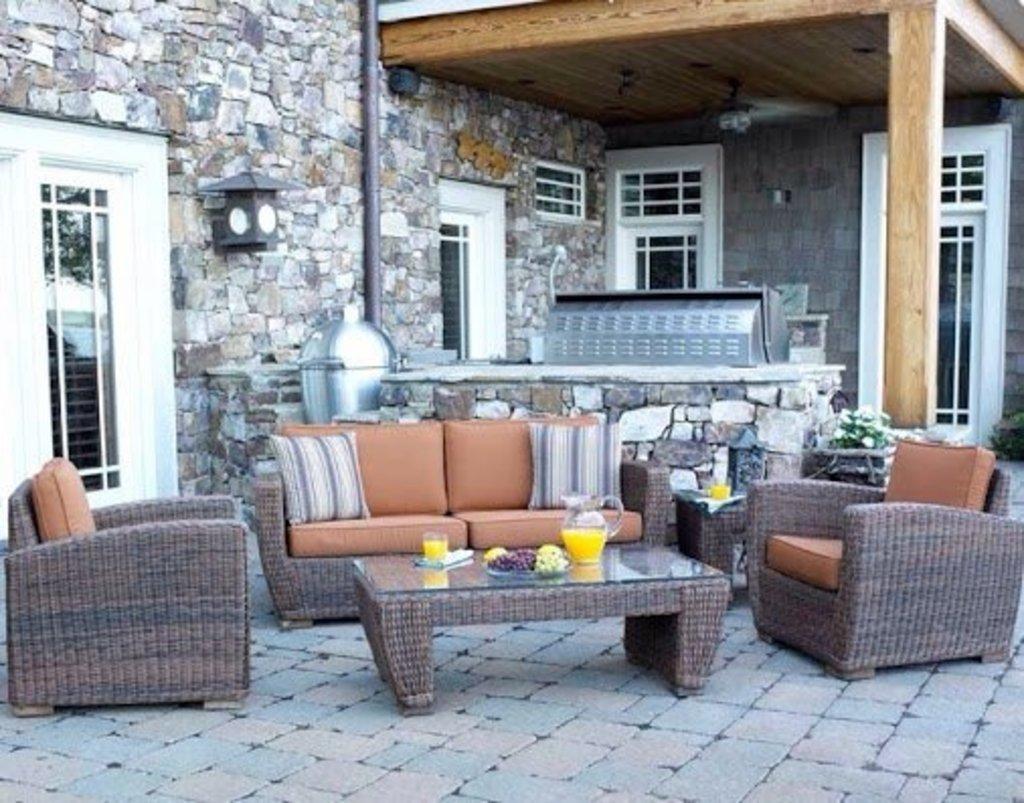Please provide a concise description of this image. There are sofa, pillow, chair and a table. In the background there is a brick wall. On the table there is a jar, tray, glass, on the train there are some fruits. There is a pillar. On the wall there are windows and there is a plant with flowers. 